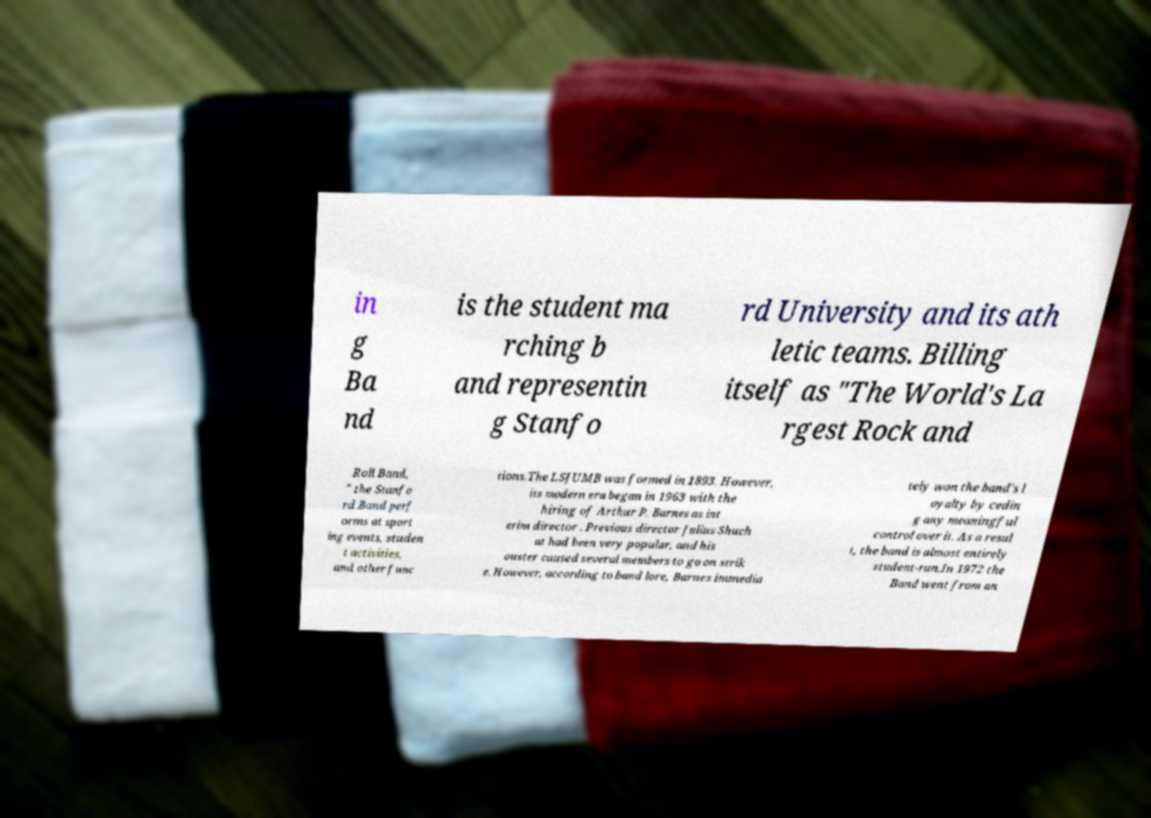Can you accurately transcribe the text from the provided image for me? in g Ba nd is the student ma rching b and representin g Stanfo rd University and its ath letic teams. Billing itself as "The World's La rgest Rock and Roll Band, " the Stanfo rd Band perf orms at sport ing events, studen t activities, and other func tions.The LSJUMB was formed in 1893. However, its modern era began in 1963 with the hiring of Arthur P. Barnes as int erim director . Previous director Julius Shuch at had been very popular, and his ouster caused several members to go on strik e. However, according to band lore, Barnes immedia tely won the band's l oyalty by cedin g any meaningful control over it. As a resul t, the band is almost entirely student-run.In 1972 the Band went from an 